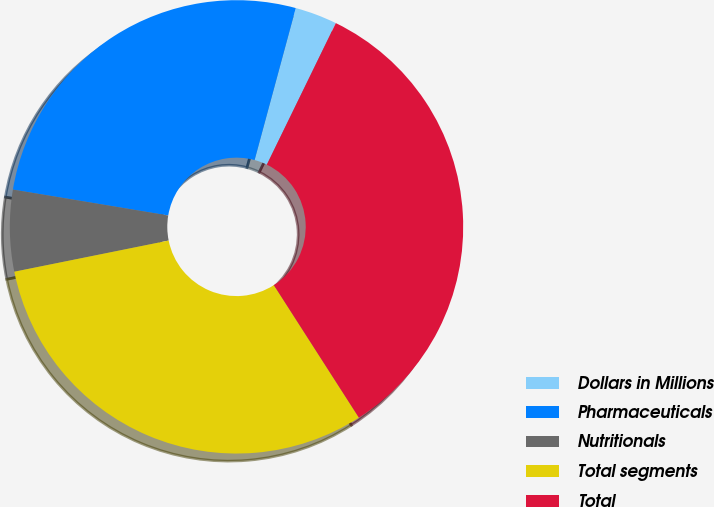Convert chart. <chart><loc_0><loc_0><loc_500><loc_500><pie_chart><fcel>Dollars in Millions<fcel>Pharmaceuticals<fcel>Nutritionals<fcel>Total segments<fcel>Total<nl><fcel>3.01%<fcel>26.58%<fcel>5.8%<fcel>30.91%<fcel>33.7%<nl></chart> 